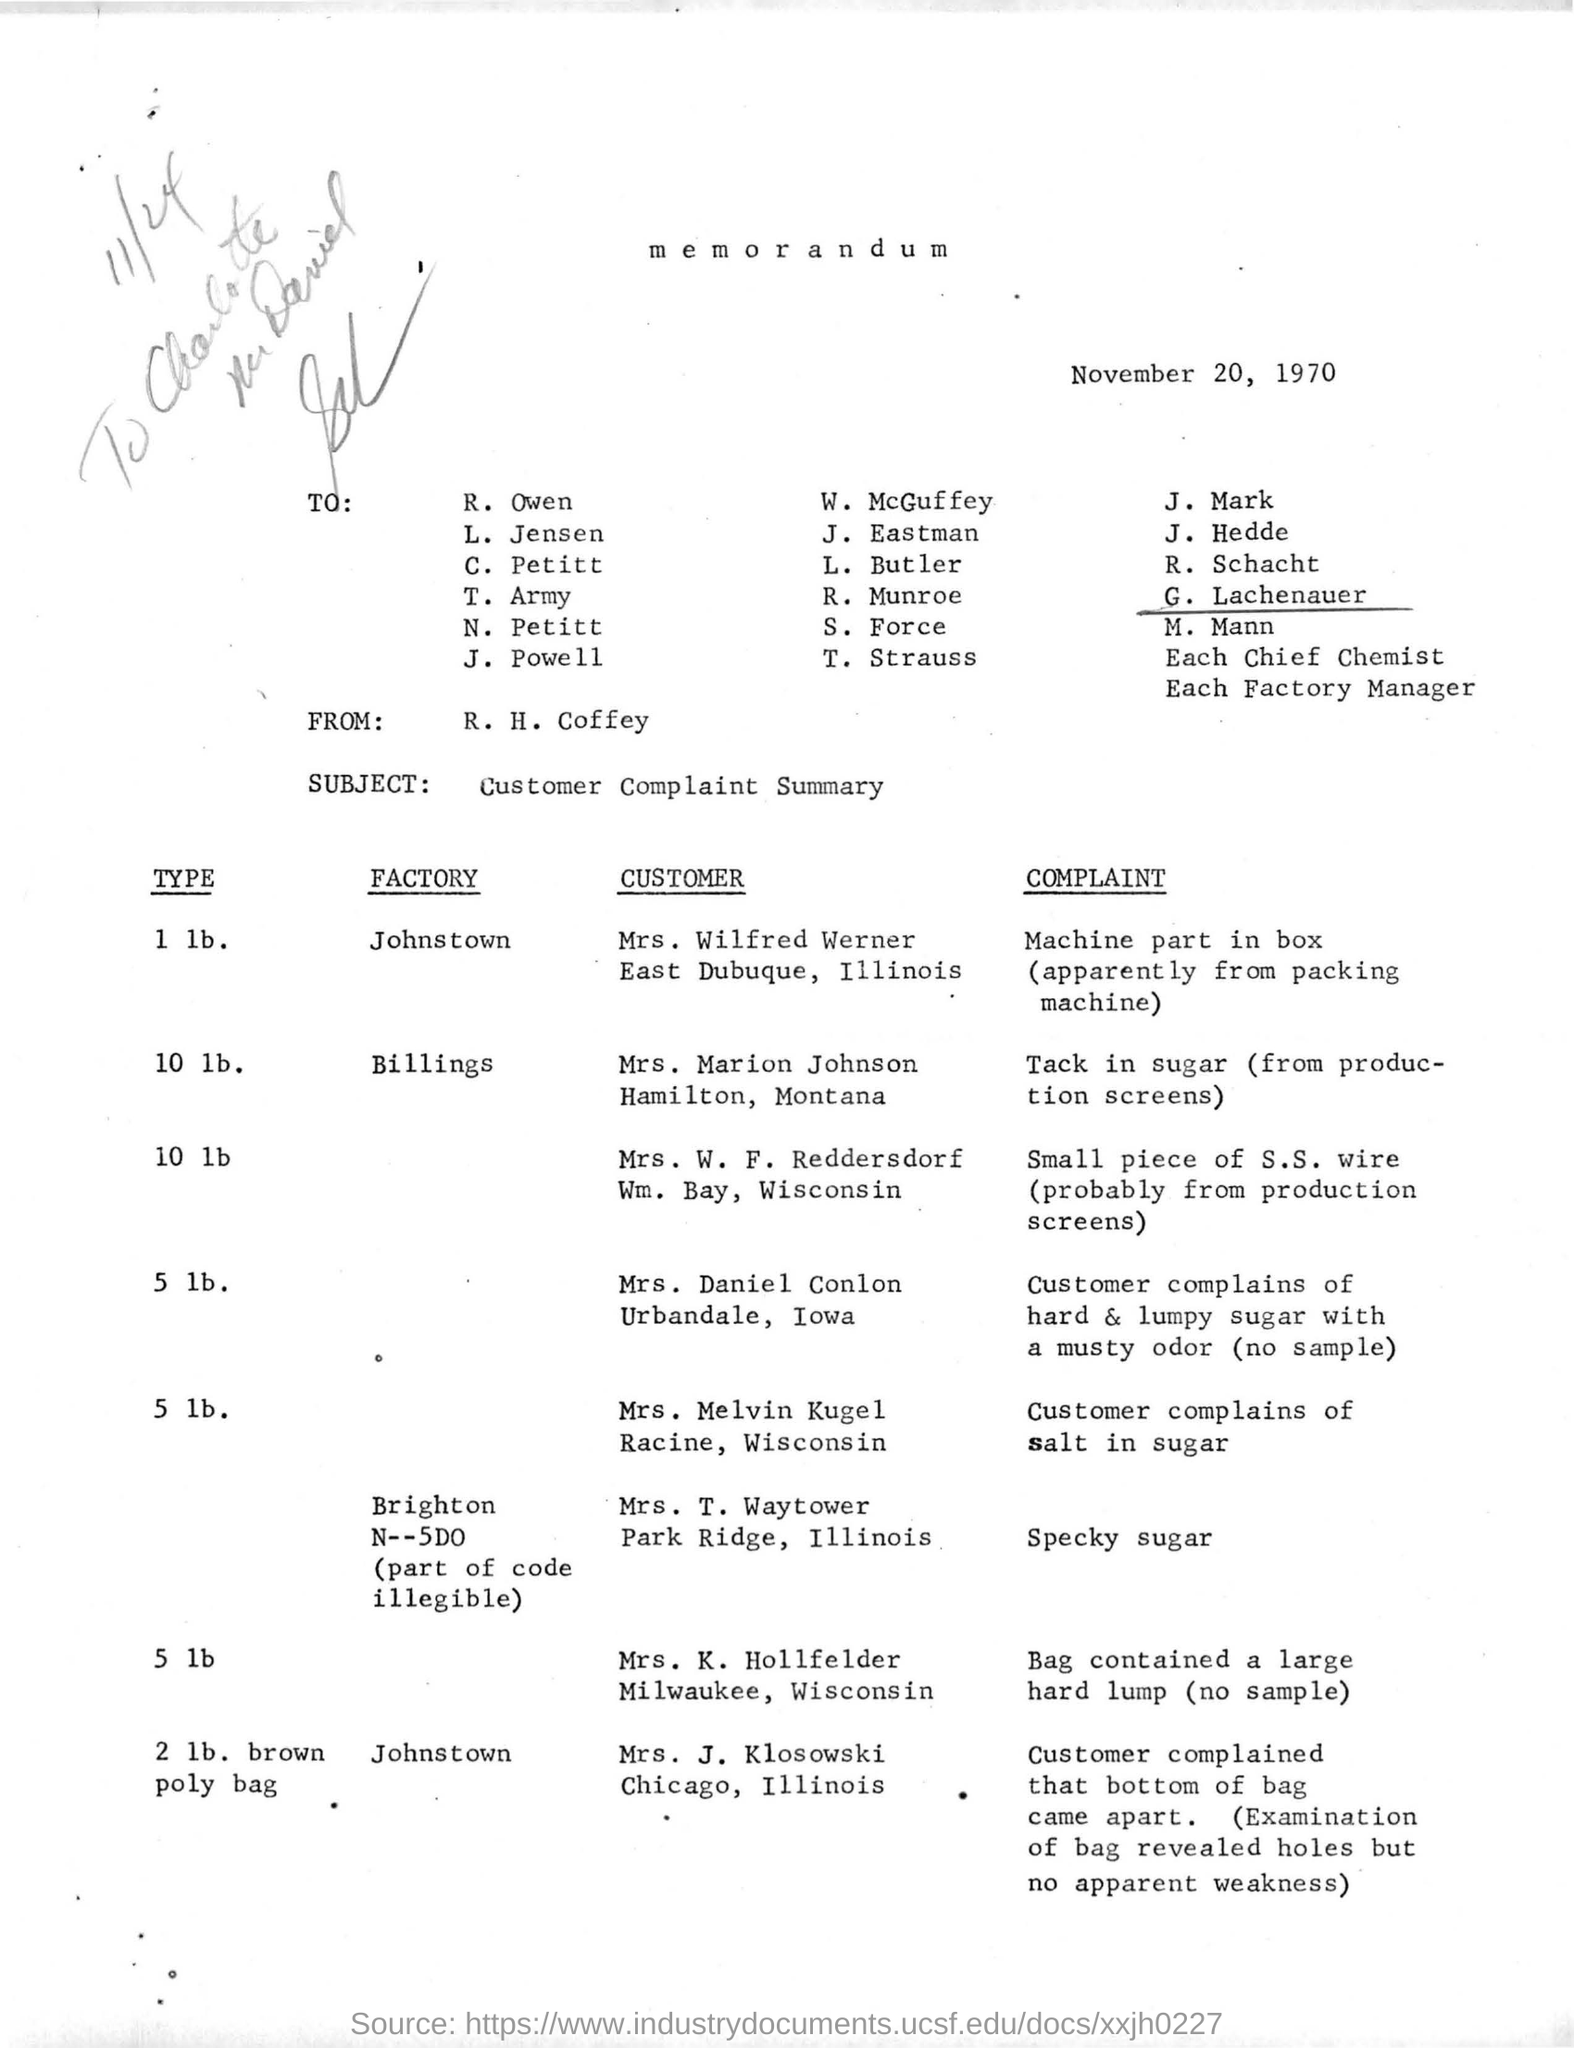Mention a couple of crucial points in this snapshot. The subject of the memorandum is a customer complaint summary. The memorandum is from R. H. Coffey. 